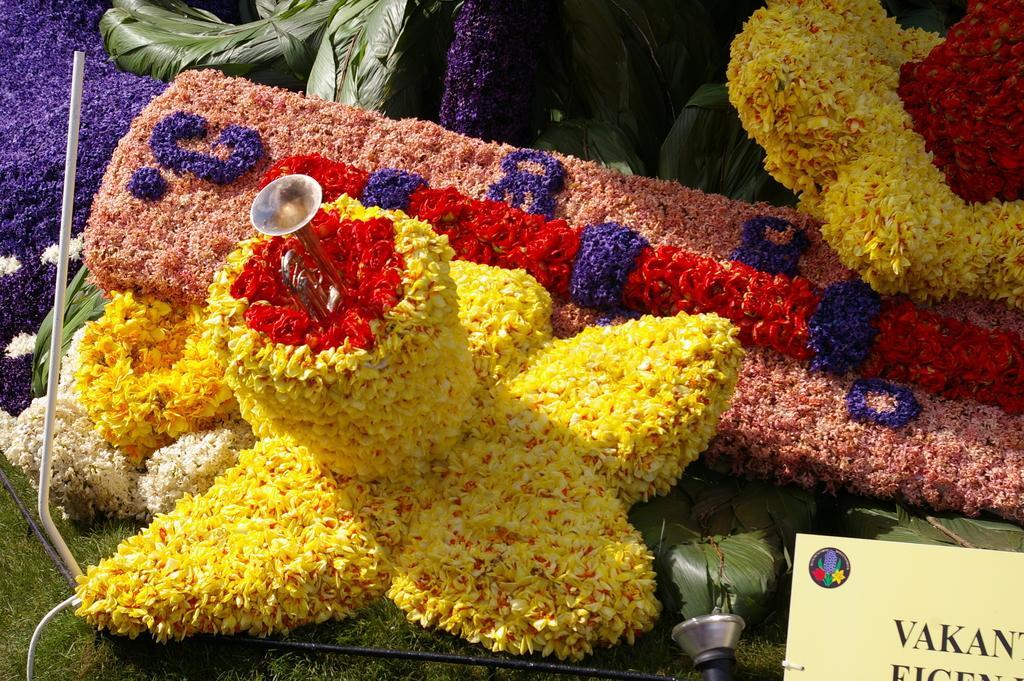How would you summarize this image in a sentence or two? In this image I see flowers which are of different in colors and I see a thing over here and I see the green grass and I see a board over here on which there are words on it and I see the green color things and I see the white color thing over here. 